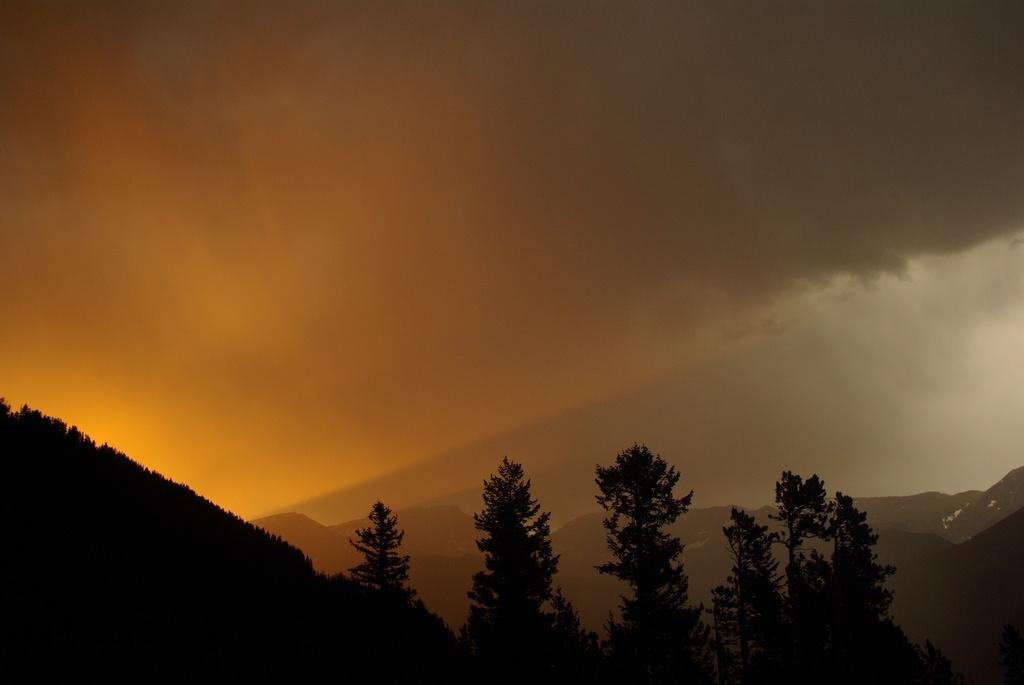What type of vegetation can be seen in the image? There are trees in the image. What geographical feature is visible in the image? There are mountains in the image. What part of the natural environment is visible in the image? The sky is visible in the image. How many tomatoes are hanging from the trees in the image? There are no tomatoes present in the image; it features trees and mountains. What type of rule is being enforced in the image? There is no indication of any rules or enforcement in the image, as it primarily focuses on natural elements like trees, mountains, and the sky. 